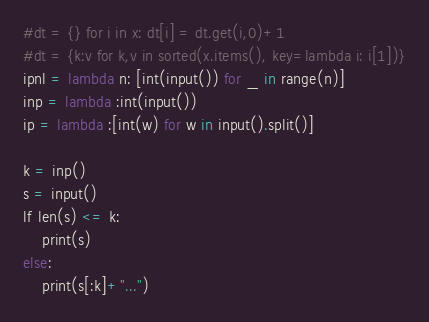<code> <loc_0><loc_0><loc_500><loc_500><_Python_>#dt = {} for i in x: dt[i] = dt.get(i,0)+1
#dt = {k:v for k,v in sorted(x.items(), key=lambda i: i[1])}
ipnl = lambda n: [int(input()) for _ in range(n)]
inp = lambda :int(input())
ip = lambda :[int(w) for w in input().split()]

k = inp()
s = input()
lf len(s) <= k:
    print(s)
else:
    print(s[:k]+"...")</code> 